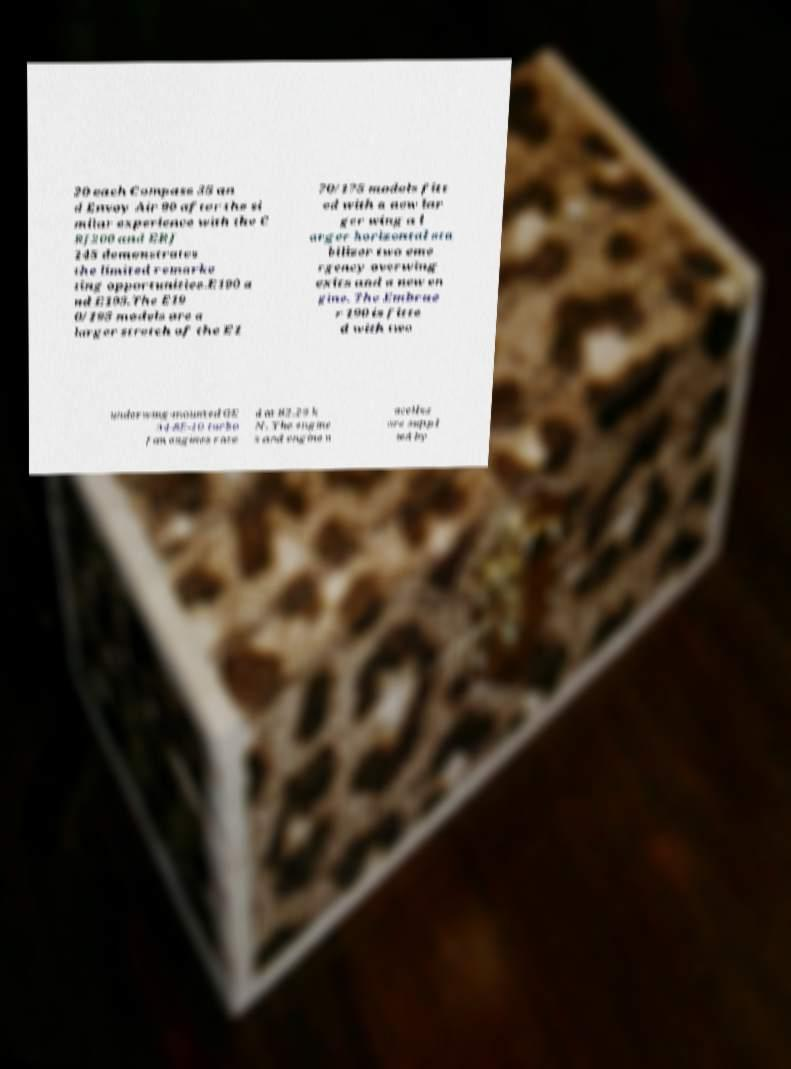What messages or text are displayed in this image? I need them in a readable, typed format. 20 each Compass 35 an d Envoy Air 90 after the si milar experience with the C RJ200 and ERJ 145 demonstrates the limited remarke ting opportunities.E190 a nd E195.The E19 0/195 models are a larger stretch of the E1 70/175 models fitt ed with a new lar ger wing a l arger horizontal sta bilizer two eme rgency overwing exits and a new en gine. The Embrae r 190 is fitte d with two underwing-mounted GE 34-8E-10 turbo fan engines rate d at 82.29 k N. The engine s and engine n acelles are suppl ied by 